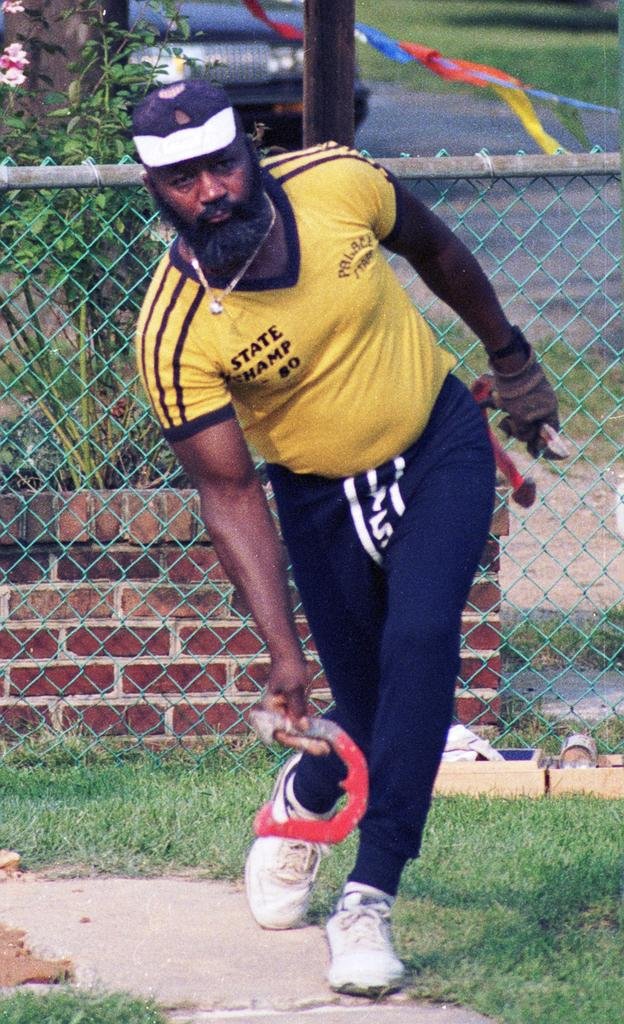Who is the main subject in the image? There is a man in the center of the image. What can be seen in the background of the image? There is a plant and a net boundary in the background of the image. What is located at the top side of the image? There is a car at the top side of the image. What type of fog can be seen surrounding the man in the image? There is no fog present in the image; it is a clear scene with the man in the center. 